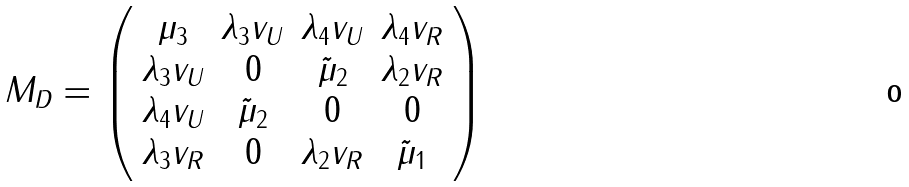Convert formula to latex. <formula><loc_0><loc_0><loc_500><loc_500>M _ { D } = \left ( \begin{array} { c c c c } \mu _ { 3 } & \lambda _ { 3 } v _ { U } & \lambda _ { 4 } v _ { U } & \lambda _ { 4 } v _ { R } \\ \lambda _ { 3 } v _ { U } & 0 & \tilde { \mu } _ { 2 } & \lambda _ { 2 } v _ { R } \\ \lambda _ { 4 } v _ { U } & \tilde { \mu } _ { 2 } & 0 & 0 \\ \lambda _ { 3 } v _ { R } & 0 & \lambda _ { 2 } v _ { R } & \tilde { \mu } _ { 1 } \end{array} \right )</formula> 